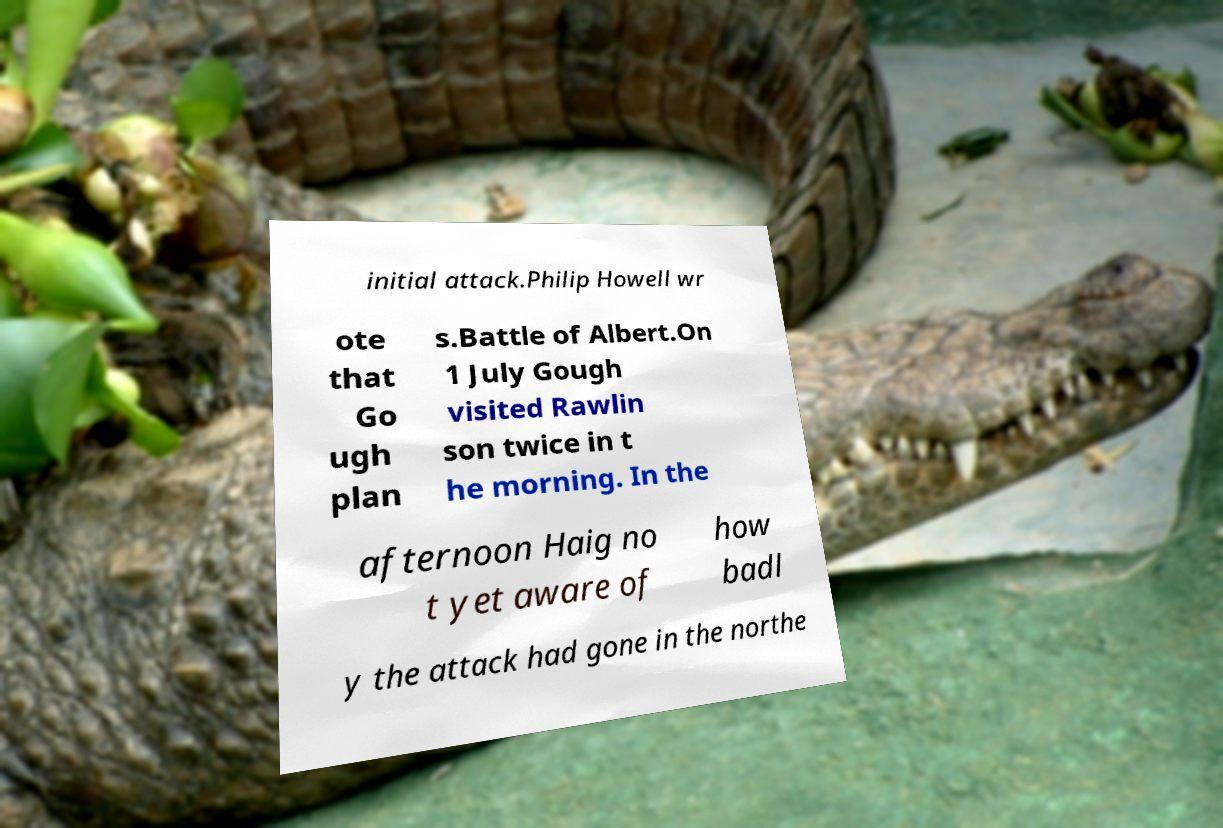What messages or text are displayed in this image? I need them in a readable, typed format. initial attack.Philip Howell wr ote that Go ugh plan s.Battle of Albert.On 1 July Gough visited Rawlin son twice in t he morning. In the afternoon Haig no t yet aware of how badl y the attack had gone in the northe 